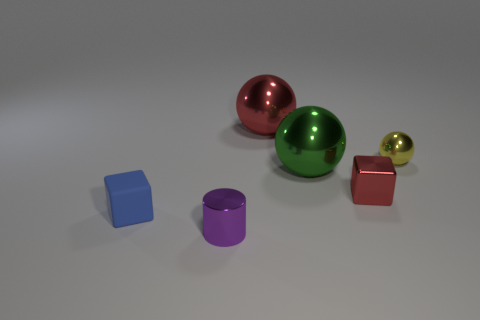What colors are the spherical objects? There are three spherical objects, and their colors are green, red, and gold. 